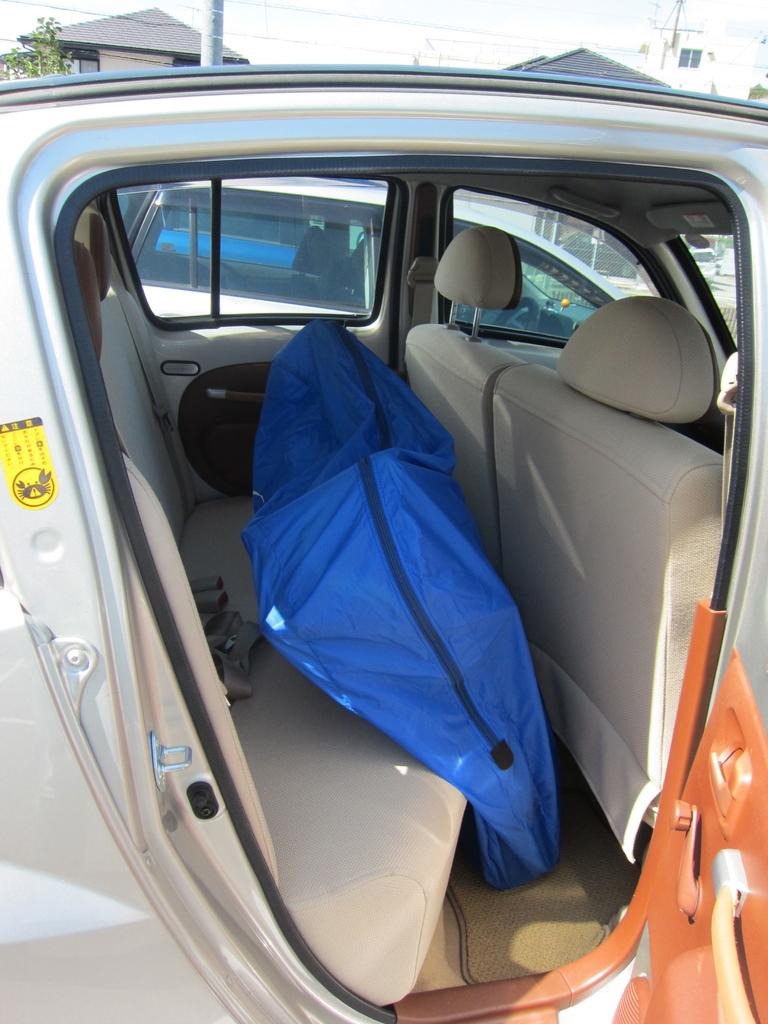What is the main subject of the image? The main subject of the image is a car. What can be found inside the car? There is a blue packaging visible inside the car door. How many cars are visible in the image? There are two cars visible in the image. What type of structures can be seen at the top of the image? There are houses visible at the top of the image. Where is the kitten sitting in the car? There is no kitten present in the image. What type of plough is being used to cultivate the field in the image? There is no field or plough visible in the image; it features a car and houses. 